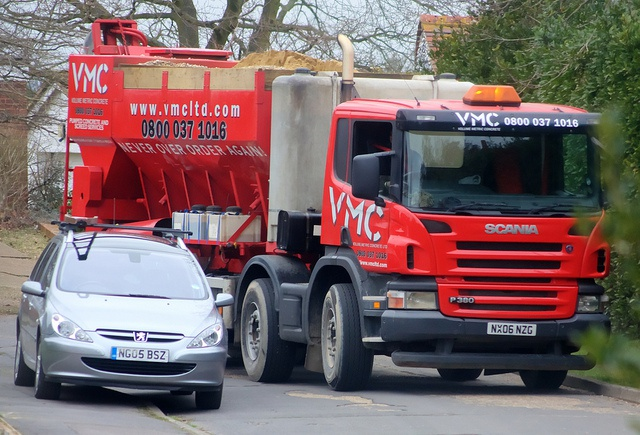Describe the objects in this image and their specific colors. I can see truck in darkgray, black, red, and gray tones and car in darkgray, lavender, gray, and black tones in this image. 